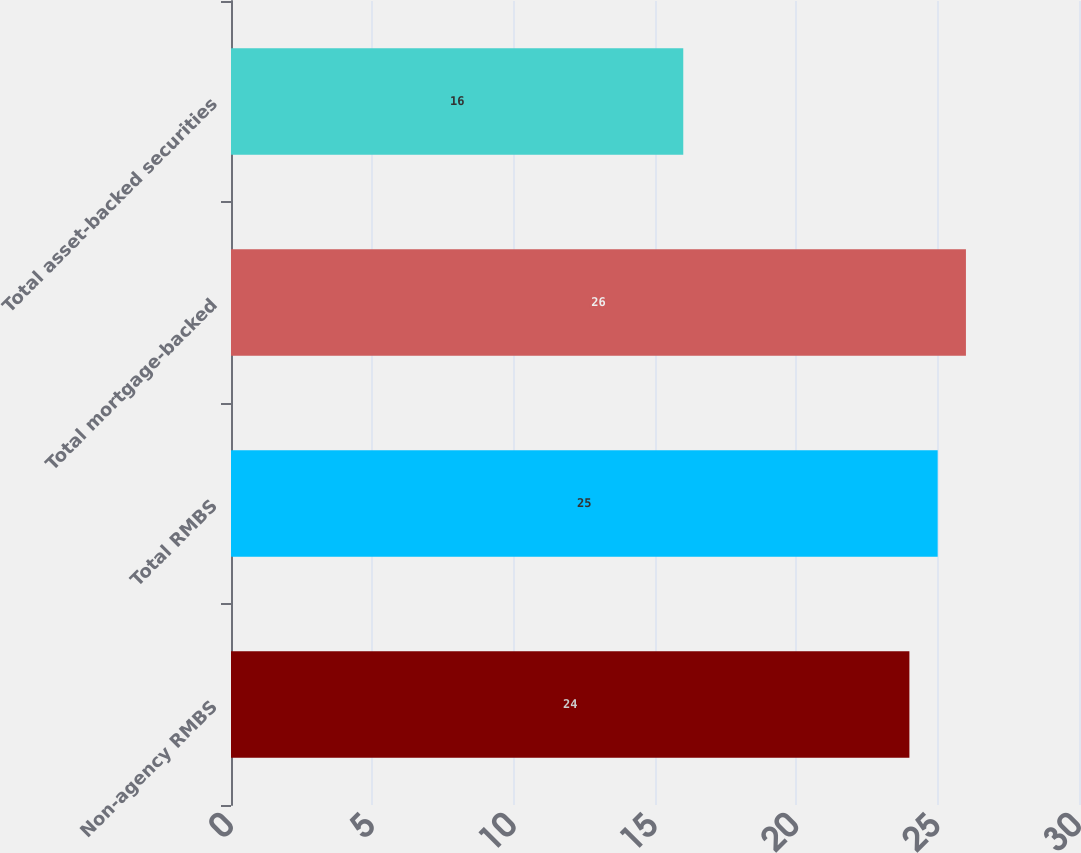Convert chart. <chart><loc_0><loc_0><loc_500><loc_500><bar_chart><fcel>Non-agency RMBS<fcel>Total RMBS<fcel>Total mortgage-backed<fcel>Total asset-backed securities<nl><fcel>24<fcel>25<fcel>26<fcel>16<nl></chart> 